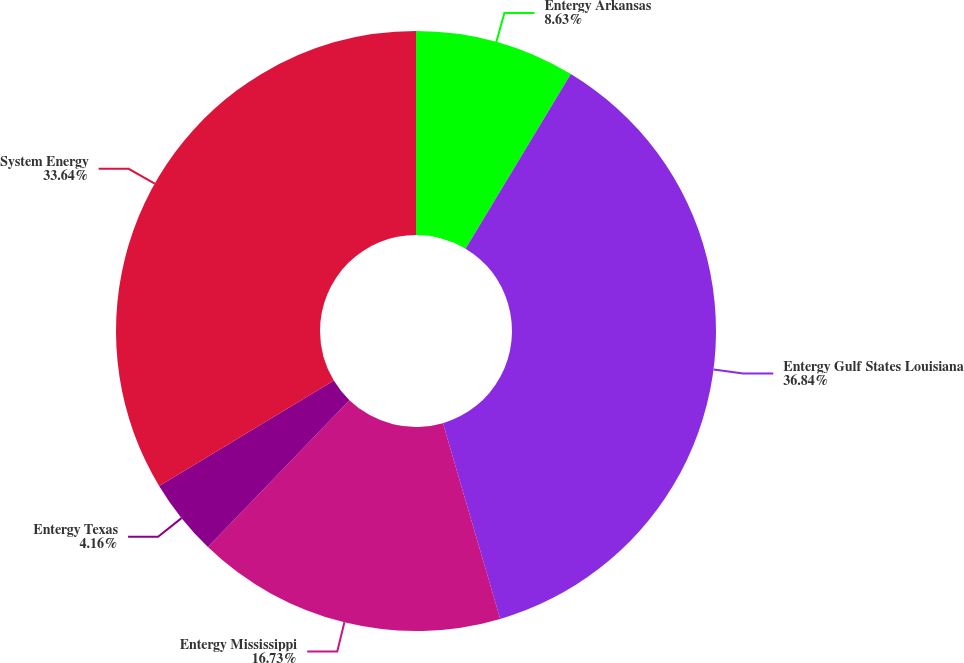Convert chart. <chart><loc_0><loc_0><loc_500><loc_500><pie_chart><fcel>Entergy Arkansas<fcel>Entergy Gulf States Louisiana<fcel>Entergy Mississippi<fcel>Entergy Texas<fcel>System Energy<nl><fcel>8.63%<fcel>36.84%<fcel>16.73%<fcel>4.16%<fcel>33.64%<nl></chart> 